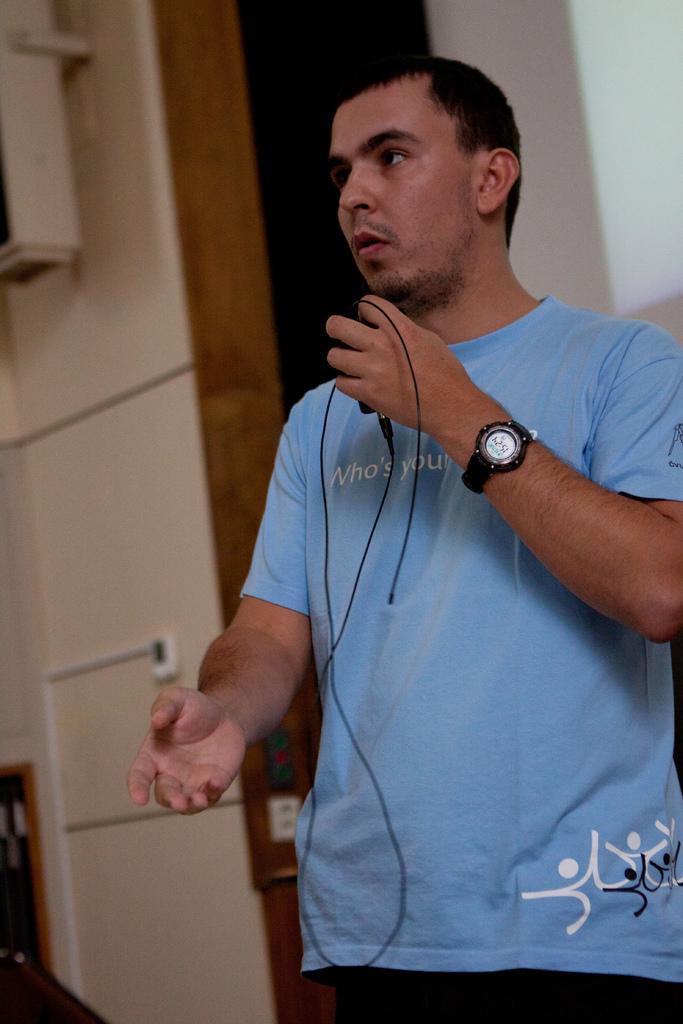Could you give a brief overview of what you see in this image? On the background we can see a wall. In Front of a picture we can see one man wearing a blue shirt. He wore watch and he held a charger in his hand. 